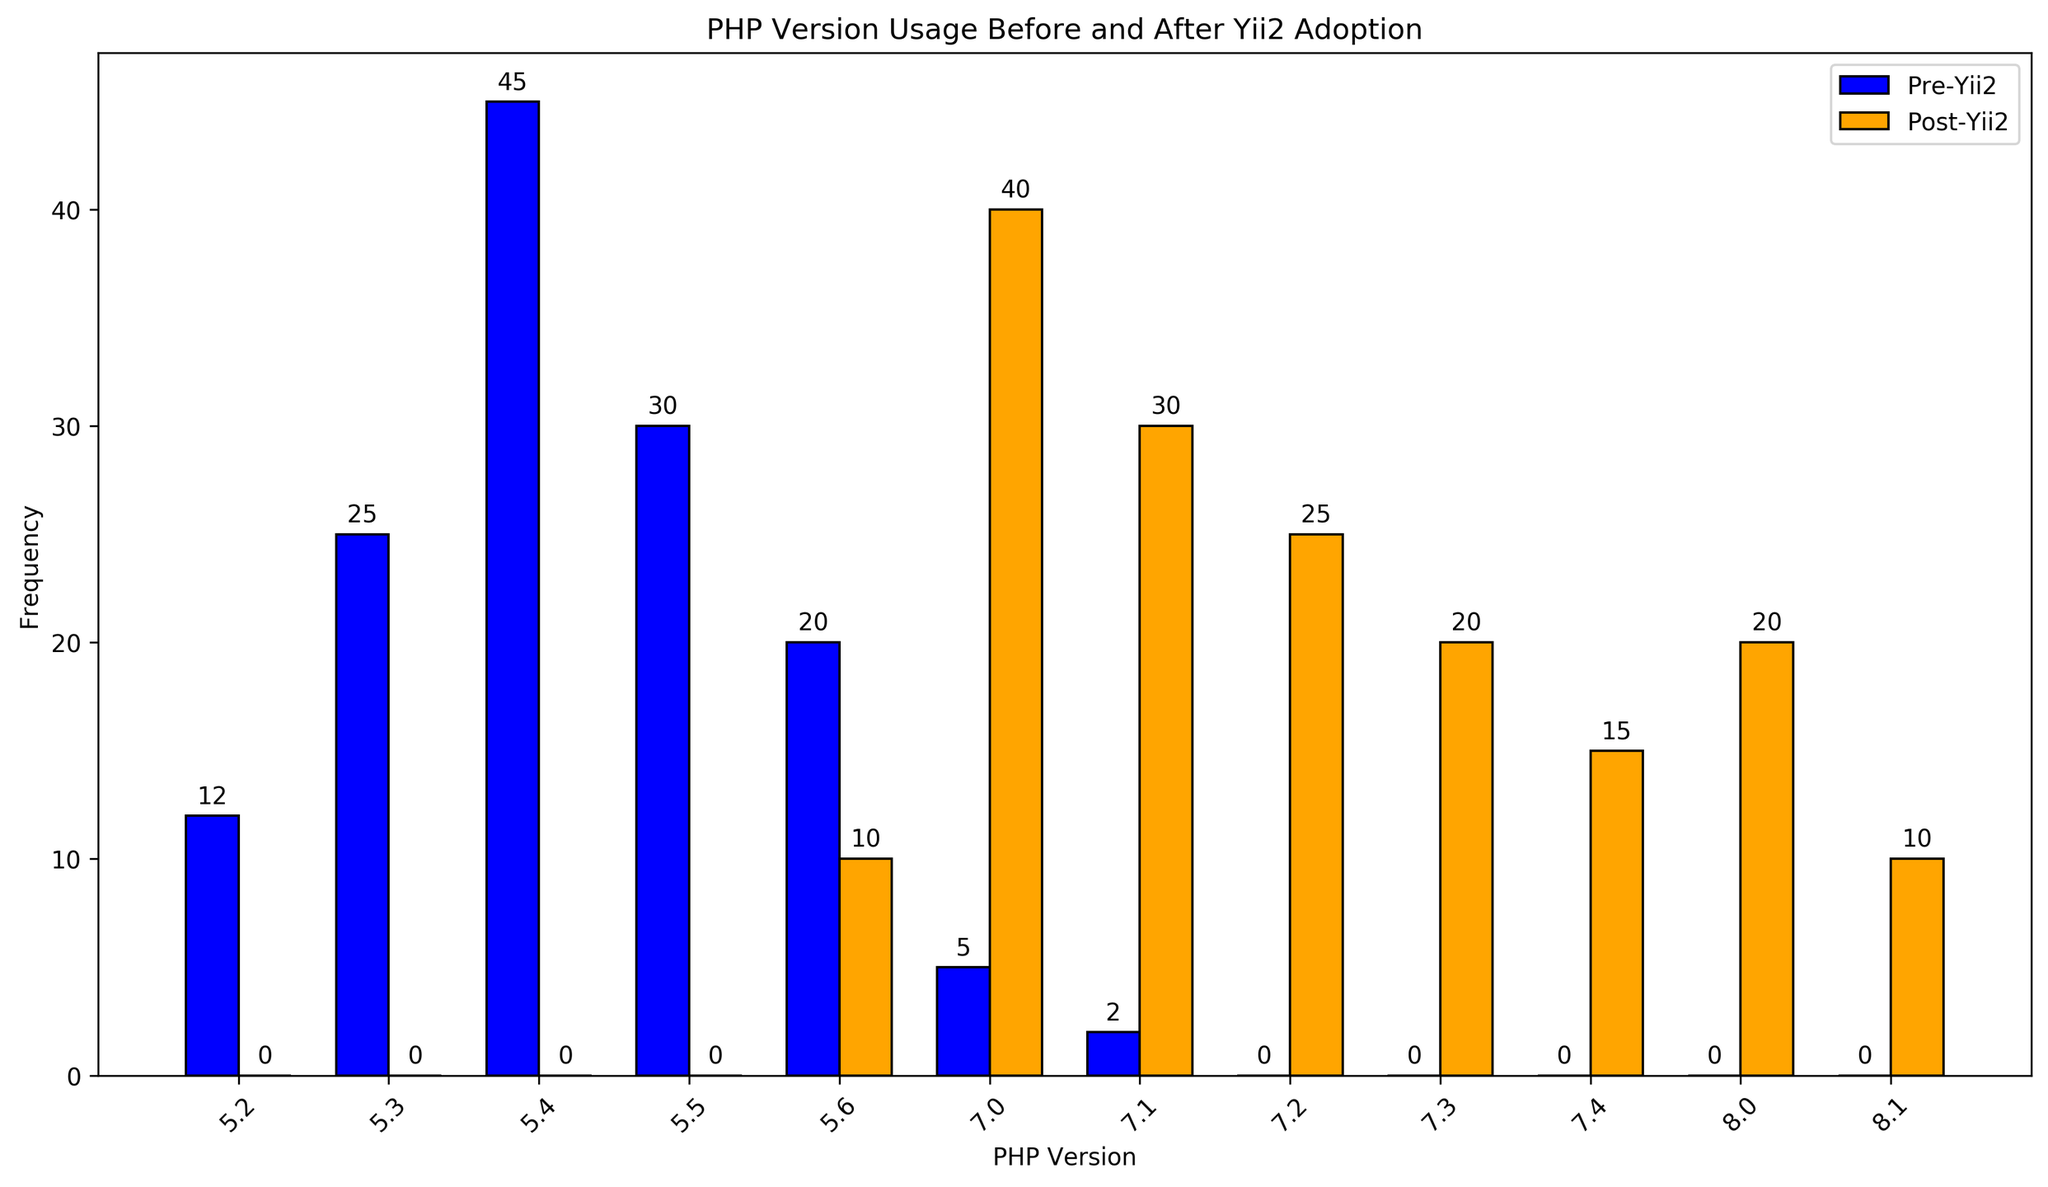Which PHP version was used most frequently before adopting Yii 2.0? The highest bar in the 'Pre-Yii2' group indicates the most frequently used PHP version. The tallest bar corresponds to PHP version 5.4.
Answer: 5.4 Which PHP version saw the largest increase in usage after adopting Yii 2.0? Compare the heights of the bars in the 'Pre-Yii2' and 'Post-Yii2' groups for each PHP version. The largest difference between post- and pre-adoption bars is for PHP version 7.0.
Answer: 7.0 What is the combined frequency of projects using PHP version 7.1 before and after adopting Yii 2.0? Add the frequencies of PHP version 7.1 usage before and after Yii 2.0 adoption. Pre-Yii2 usage for 7.1 is 2 and post-Yii2 usage for 7.1 is 30. So, 2 + 30 = 32.
Answer: 32 By how much did the frequency of PHP 7.0 projects change from pre- to post-Yii2 adoption? Subtract the pre-Yii2 frequency of PHP 7.0 from the post-Yii2 frequency. Pre-Yii2 is 5, post-Yii2 is 40. 40 - 5 = 35.
Answer: 35 Which PHP versions were not used at all before adopting Yii 2.0? Identify the PHP versions with zero frequency in the 'Pre-Yii2' bars. Versions 7.2, 7.3, 7.4, 8.0, and 8.1 have no 'Pre-Yii2' bar.
Answer: 7.2, 7.3, 7.4, 8.0, 8.1 Compare the total frequencies of all PHP versions used pre- and post-Yii 2.0 adoption. Which stage had higher overall usage? Sum the frequencies of all bars in the 'Pre-Yii2' group and 'Post-Yii2' group separately. Total pre-Yii2 usage is 12+25+45+30+20+5+2 = 139 and total post-Yii2 usage is 10+40+30+25+20+15+20+10 = 170. Post-Yii2 has higher overall usage.
Answer: Post-Yii2 What percentage of post-Yii2 projects used PHP version 8.0? Calculate the percentage by dividing the frequency of PHP 8.0 post-Yii2 usage by the total post-Yii2 frequencies and multiplying by 100. Frequency of 8.0 is 20, total post-Yii2 usage is 170. (20/170) * 100 = ~11.76%.
Answer: ~11.76% Is there any PHP version whose usage decreased from pre- to post-Yii2 adoption? Compare frequencies of each PHP version from pre- to post-Yii2 and identify decreases. PHP version 5.6 decreased from 20 to 10.
Answer: 5.6 Which PHP version had exactly equal usage before and after Yii 2.0 adoption? Look for bars of equal heights in both 'Pre-Yii2' and 'Post-Yii2' groups. None of the PHP version usage frequencies are equal.
Answer: None 